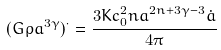Convert formula to latex. <formula><loc_0><loc_0><loc_500><loc_500>( G \rho a ^ { 3 \gamma } ) ^ { \cdot } = \frac { 3 K c _ { 0 } ^ { 2 } n a ^ { 2 n + 3 \gamma - 3 } \dot { a } } { 4 \pi }</formula> 